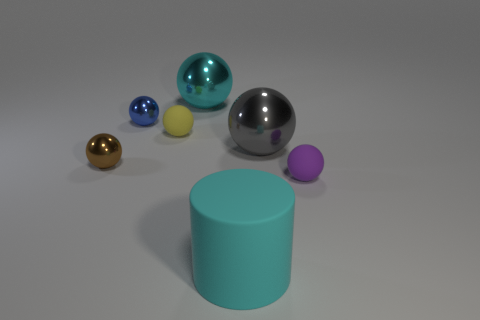Subtract all brown spheres. How many spheres are left? 5 Subtract all purple balls. How many balls are left? 5 Subtract all blue balls. Subtract all yellow cubes. How many balls are left? 5 Add 2 purple objects. How many objects exist? 9 Subtract all cylinders. How many objects are left? 6 Subtract 0 green cylinders. How many objects are left? 7 Subtract all tiny balls. Subtract all small shiny balls. How many objects are left? 1 Add 1 large gray objects. How many large gray objects are left? 2 Add 5 rubber cubes. How many rubber cubes exist? 5 